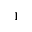<formula> <loc_0><loc_0><loc_500><loc_500>_ { 1 }</formula> 